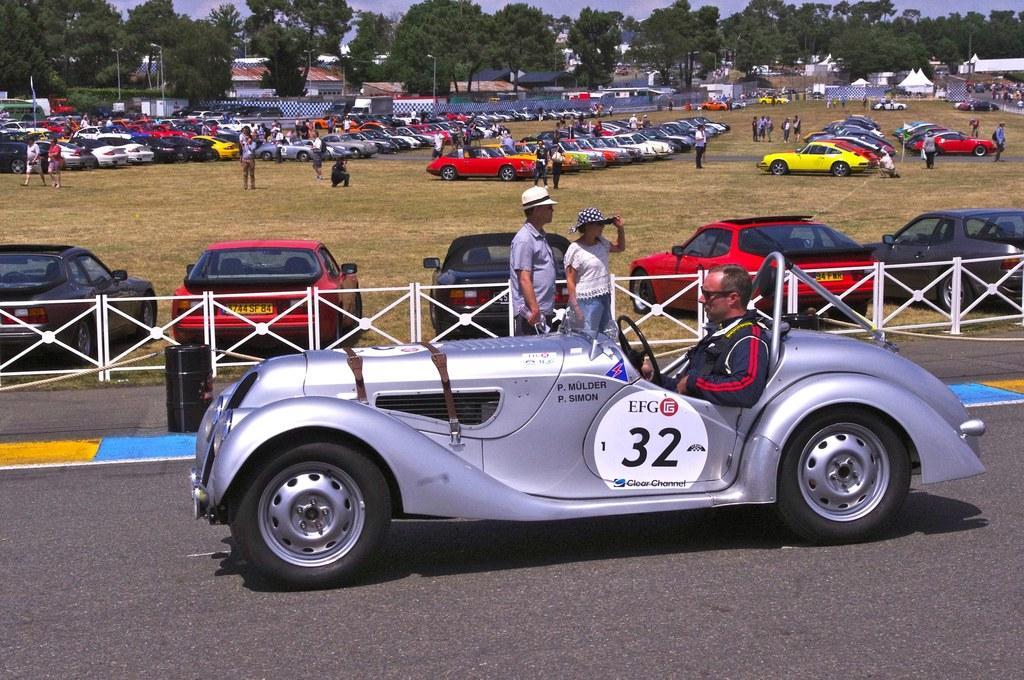In one or two sentences, can you explain what this image depicts? This image is clicked on the road. There is a car on the road. There is a person sitting in the car. Beside the road there is a railing. Behind the railing there is ground. There are many cars parked on the ground. There are many people standing on the ground. In the background there are houses, trees and poles. At the top there is the sky. 